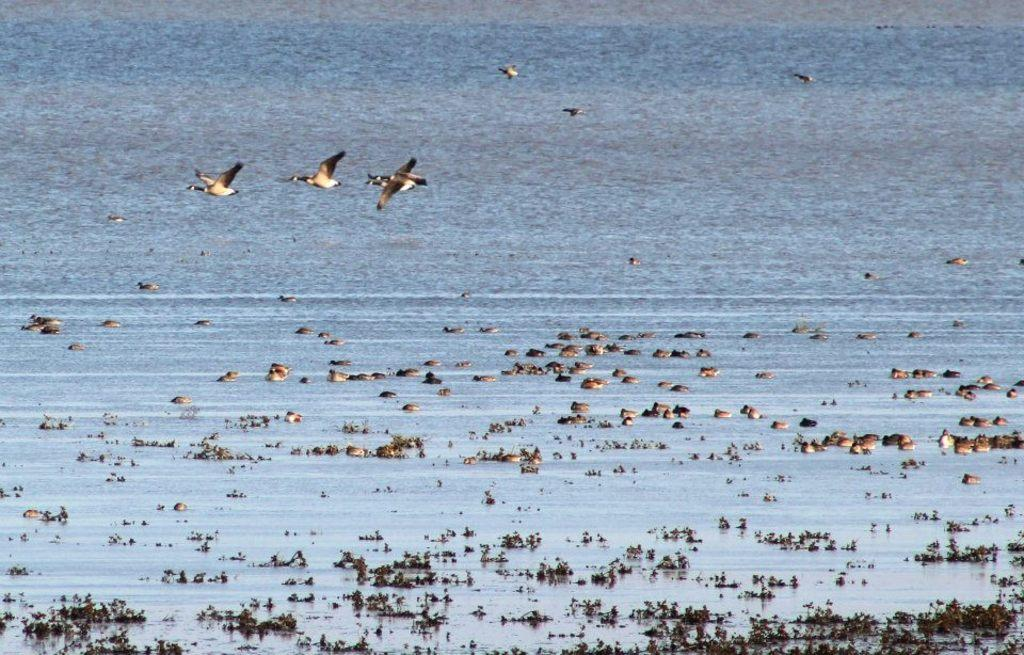What is located at the bottom of the image? There is a lake at the bottom of the image. What can be found in the lake? There are water plants and birds in the lake. Can you describe the birds in the lake? The birds in the lake are swimming or standing on the water plants. What else can be seen in the image besides the lake? There are birds flying in the air. What type of insurance does the brother have for his faucet in the image? There is no brother or faucet present in the image, so it is not possible to answer that question. 